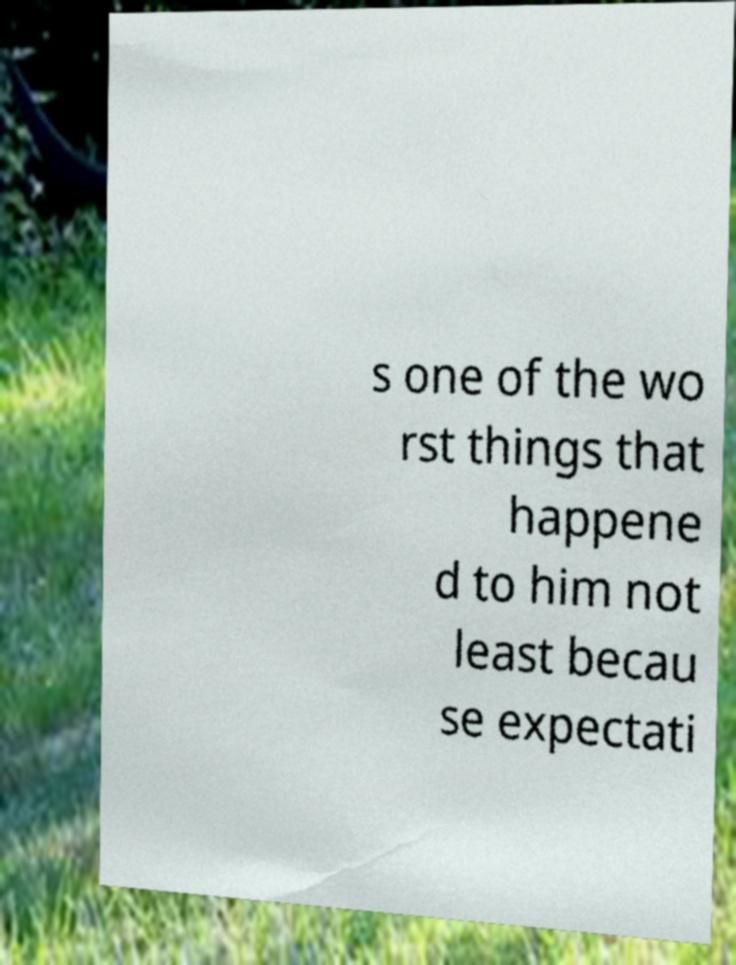Please read and relay the text visible in this image. What does it say? s one of the wo rst things that happene d to him not least becau se expectati 